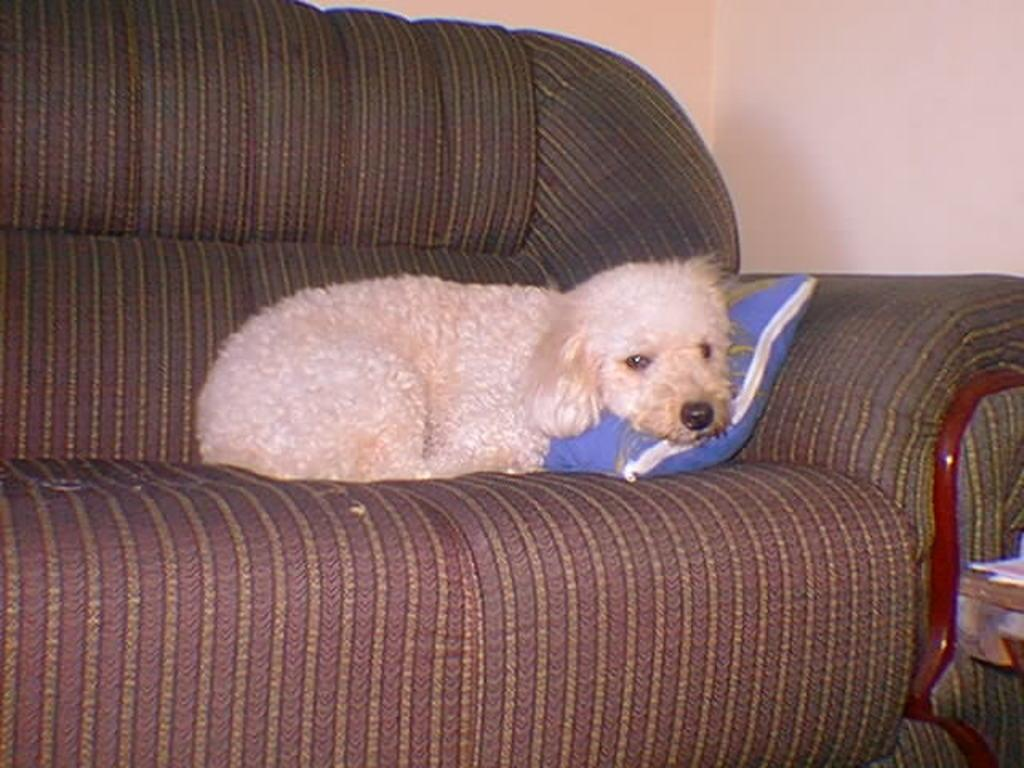What type of animal can be seen in the image? There is a dog in the image. What is the dog doing in the image? The dog is lying on a sofa. What can be seen in the background of the image? There is a wall in the background of the image. What is placed on the sofa with the dog? There is a cushion placed on the sofa. What type of bears can be seen playing with the dog in the image? There are no bears present in the image; it features a dog lying on a sofa. What type of school can be seen in the image? There is no school present in the image; it features a dog lying on a sofa with a cushion and a wall in the background. 